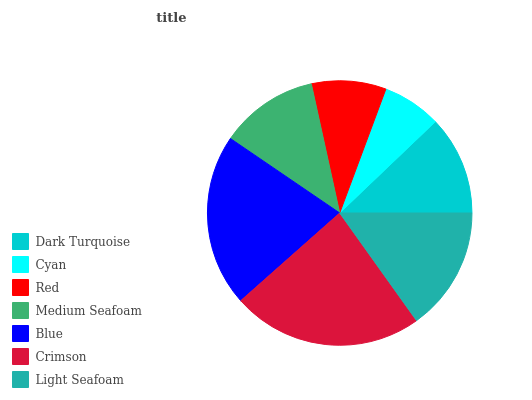Is Cyan the minimum?
Answer yes or no. Yes. Is Crimson the maximum?
Answer yes or no. Yes. Is Red the minimum?
Answer yes or no. No. Is Red the maximum?
Answer yes or no. No. Is Red greater than Cyan?
Answer yes or no. Yes. Is Cyan less than Red?
Answer yes or no. Yes. Is Cyan greater than Red?
Answer yes or no. No. Is Red less than Cyan?
Answer yes or no. No. Is Dark Turquoise the high median?
Answer yes or no. Yes. Is Dark Turquoise the low median?
Answer yes or no. Yes. Is Blue the high median?
Answer yes or no. No. Is Blue the low median?
Answer yes or no. No. 